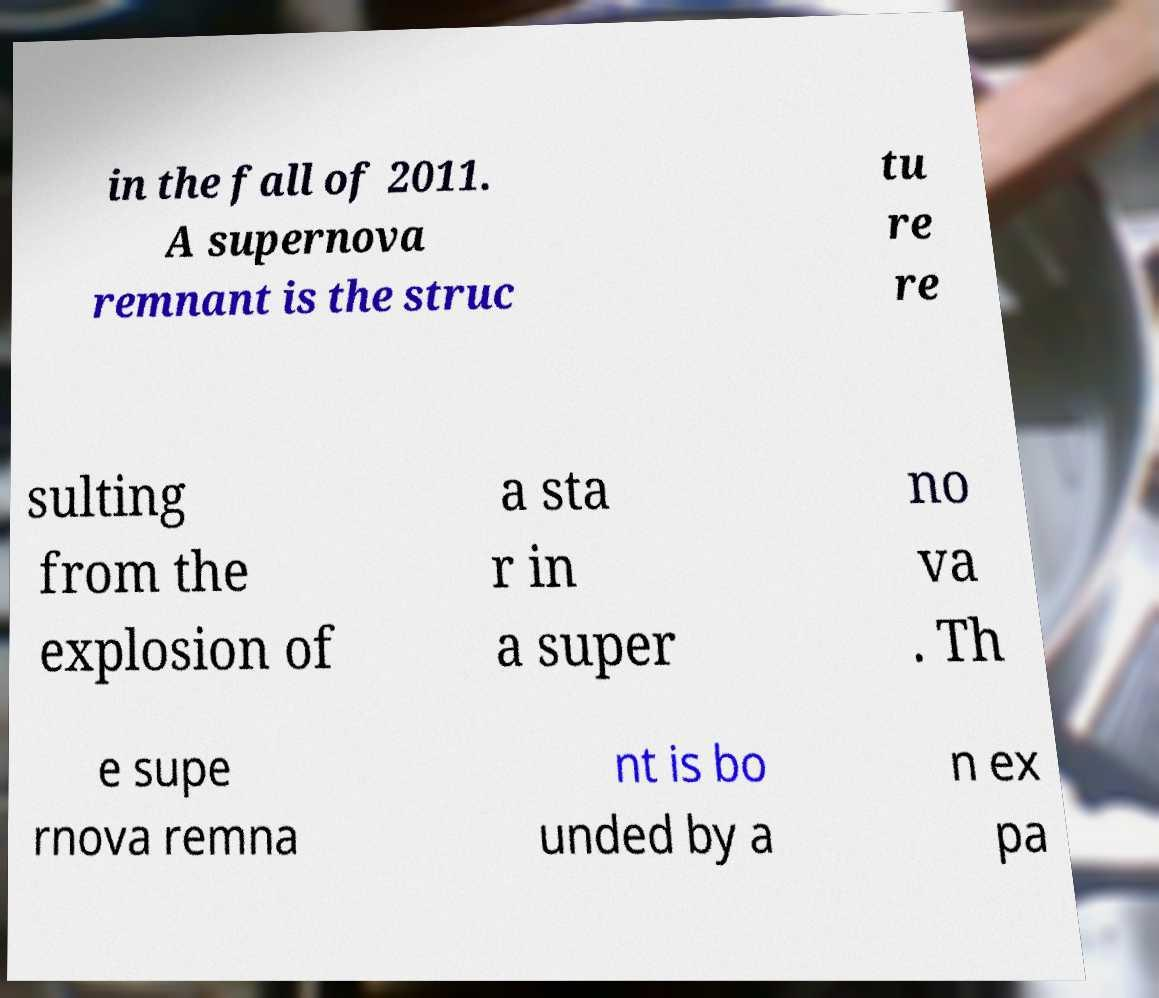Could you assist in decoding the text presented in this image and type it out clearly? in the fall of 2011. A supernova remnant is the struc tu re re sulting from the explosion of a sta r in a super no va . Th e supe rnova remna nt is bo unded by a n ex pa 